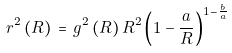Convert formula to latex. <formula><loc_0><loc_0><loc_500><loc_500>r ^ { 2 } \, ( R ) \, = \, g ^ { 2 } \, ( R ) \, R ^ { 2 } \left ( 1 - \frac { a } { R } \right ) ^ { 1 - \frac { b } { a } }</formula> 